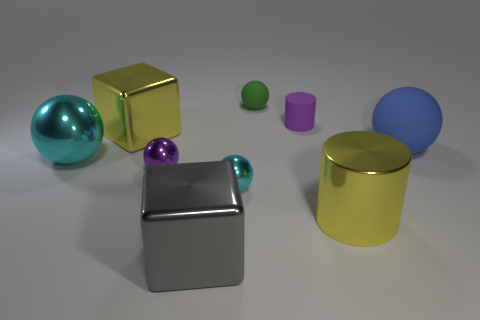What number of other objects are the same size as the yellow block?
Provide a succinct answer. 4. The yellow cube has what size?
Make the answer very short. Large. Is the material of the gray thing the same as the cube to the left of the gray thing?
Make the answer very short. Yes. Is there a large green shiny object that has the same shape as the tiny cyan thing?
Provide a short and direct response. No. There is a cyan sphere that is the same size as the yellow metallic block; what is it made of?
Your answer should be compact. Metal. There is a cyan thing that is right of the big cyan object; what is its size?
Your response must be concise. Small. There is a yellow object in front of the large blue sphere; does it have the same size as the rubber ball in front of the small purple rubber object?
Give a very brief answer. Yes. What number of big yellow objects are made of the same material as the big yellow cube?
Offer a terse response. 1. The big shiny cylinder is what color?
Make the answer very short. Yellow. There is a purple cylinder; are there any cyan balls on the right side of it?
Offer a terse response. No. 